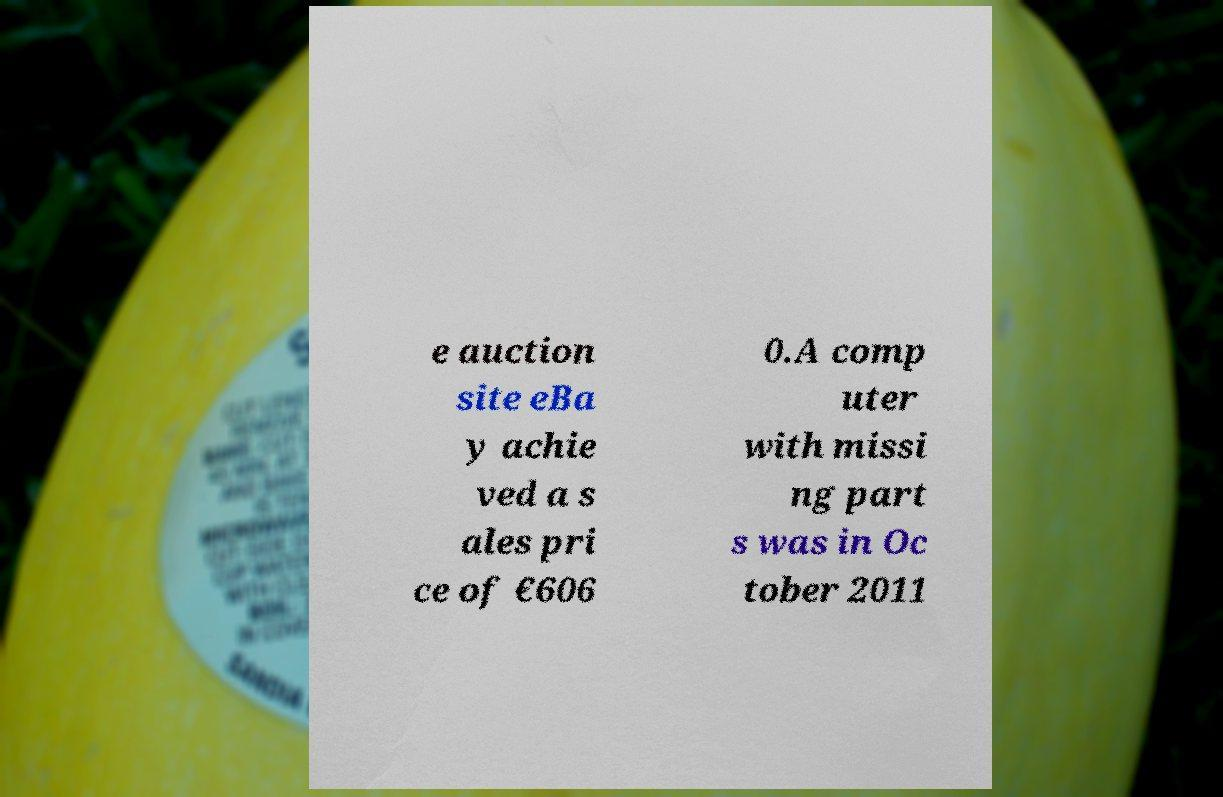Please read and relay the text visible in this image. What does it say? e auction site eBa y achie ved a s ales pri ce of €606 0.A comp uter with missi ng part s was in Oc tober 2011 